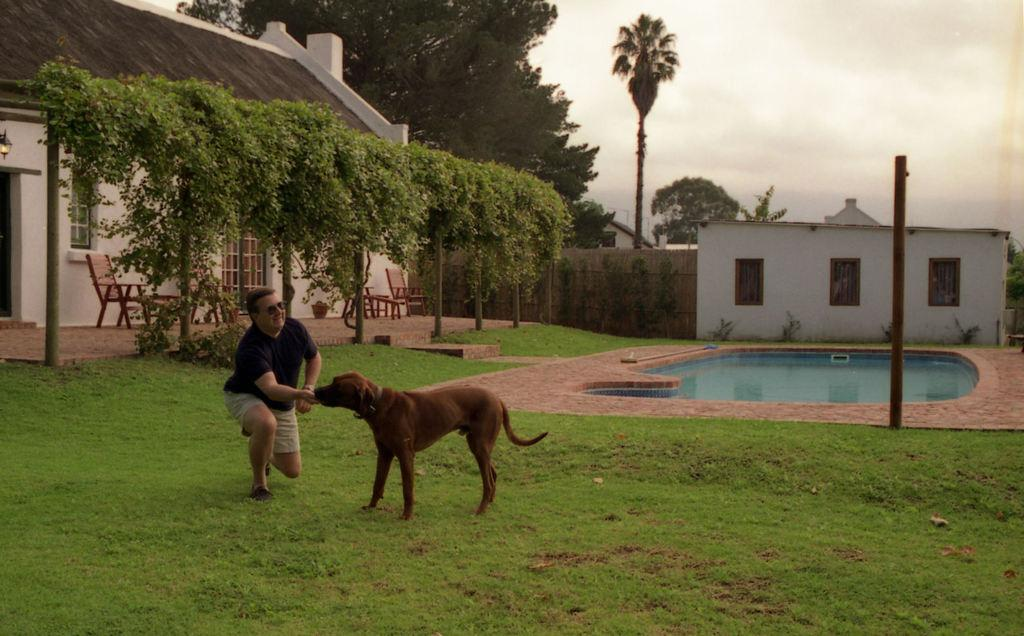Who is in the image? There is a man in the image. What is the man doing? The man is feeding food to a dog. What can be seen in the background of the image? There is a house, a chair, a door, trees, plants, a small pool, and the sky visible in the background of the image. What is the condition of the sky in the image? The sky is covered with clouds. How many robins are sitting on the man's shoulder in the image? There are no robins present in the image. What type of bears can be seen playing in the small pool in the background? There are no bears present in the image, and therefore no such activity can be observed. 